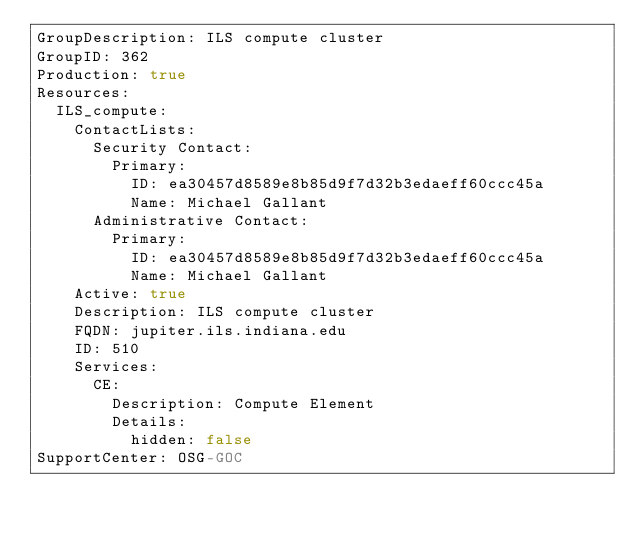<code> <loc_0><loc_0><loc_500><loc_500><_YAML_>GroupDescription: ILS compute cluster
GroupID: 362
Production: true
Resources:
  ILS_compute:
    ContactLists:
      Security Contact:
        Primary:
          ID: ea30457d8589e8b85d9f7d32b3edaeff60ccc45a
          Name: Michael Gallant
      Administrative Contact:
        Primary:
          ID: ea30457d8589e8b85d9f7d32b3edaeff60ccc45a
          Name: Michael Gallant
    Active: true
    Description: ILS compute cluster
    FQDN: jupiter.ils.indiana.edu
    ID: 510
    Services:
      CE:
        Description: Compute Element
        Details:
          hidden: false
SupportCenter: OSG-GOC
</code> 